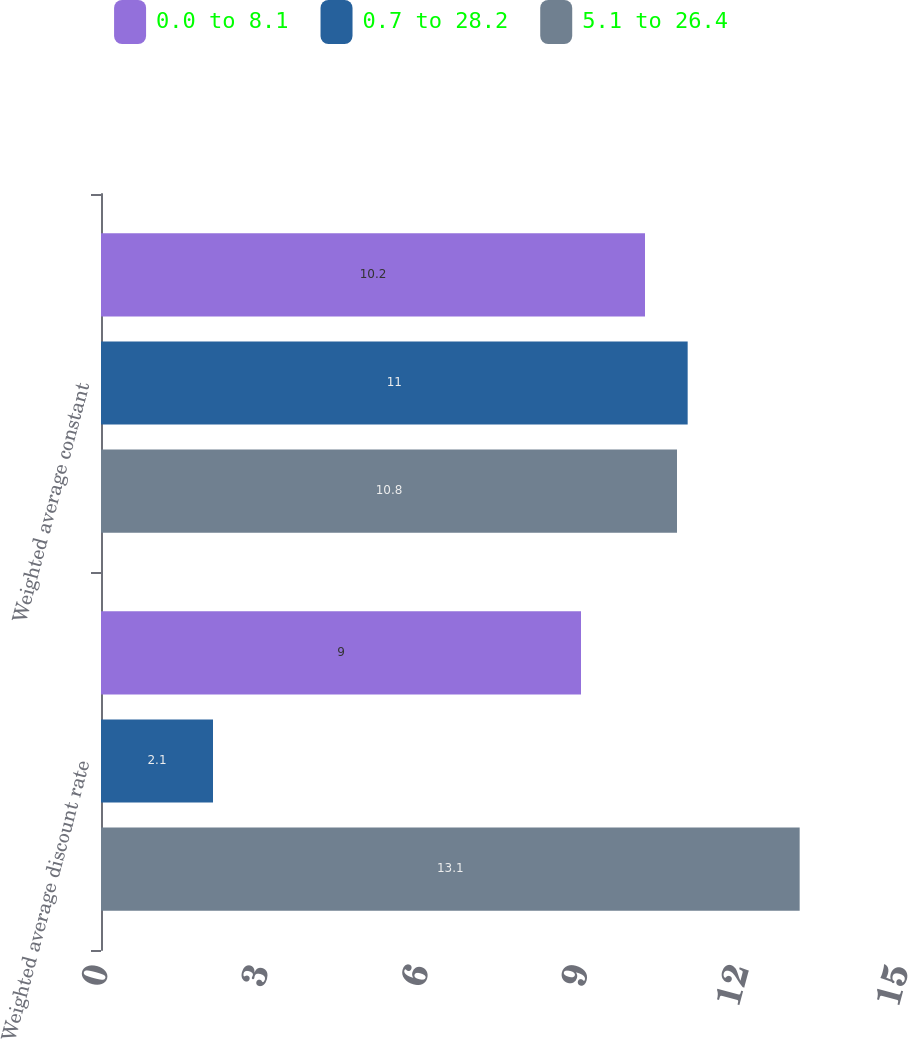Convert chart. <chart><loc_0><loc_0><loc_500><loc_500><stacked_bar_chart><ecel><fcel>Weighted average discount rate<fcel>Weighted average constant<nl><fcel>0.0 to 8.1<fcel>9<fcel>10.2<nl><fcel>0.7 to 28.2<fcel>2.1<fcel>11<nl><fcel>5.1 to 26.4<fcel>13.1<fcel>10.8<nl></chart> 